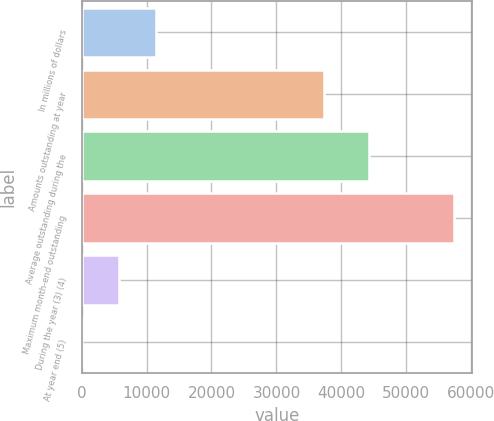<chart> <loc_0><loc_0><loc_500><loc_500><bar_chart><fcel>In millions of dollars<fcel>Amounts outstanding at year<fcel>Average outstanding during the<fcel>Maximum month-end outstanding<fcel>During the year (3) (4)<fcel>At year end (5)<nl><fcel>11464.5<fcel>37343<fcel>44274<fcel>57303<fcel>5734.73<fcel>4.92<nl></chart> 